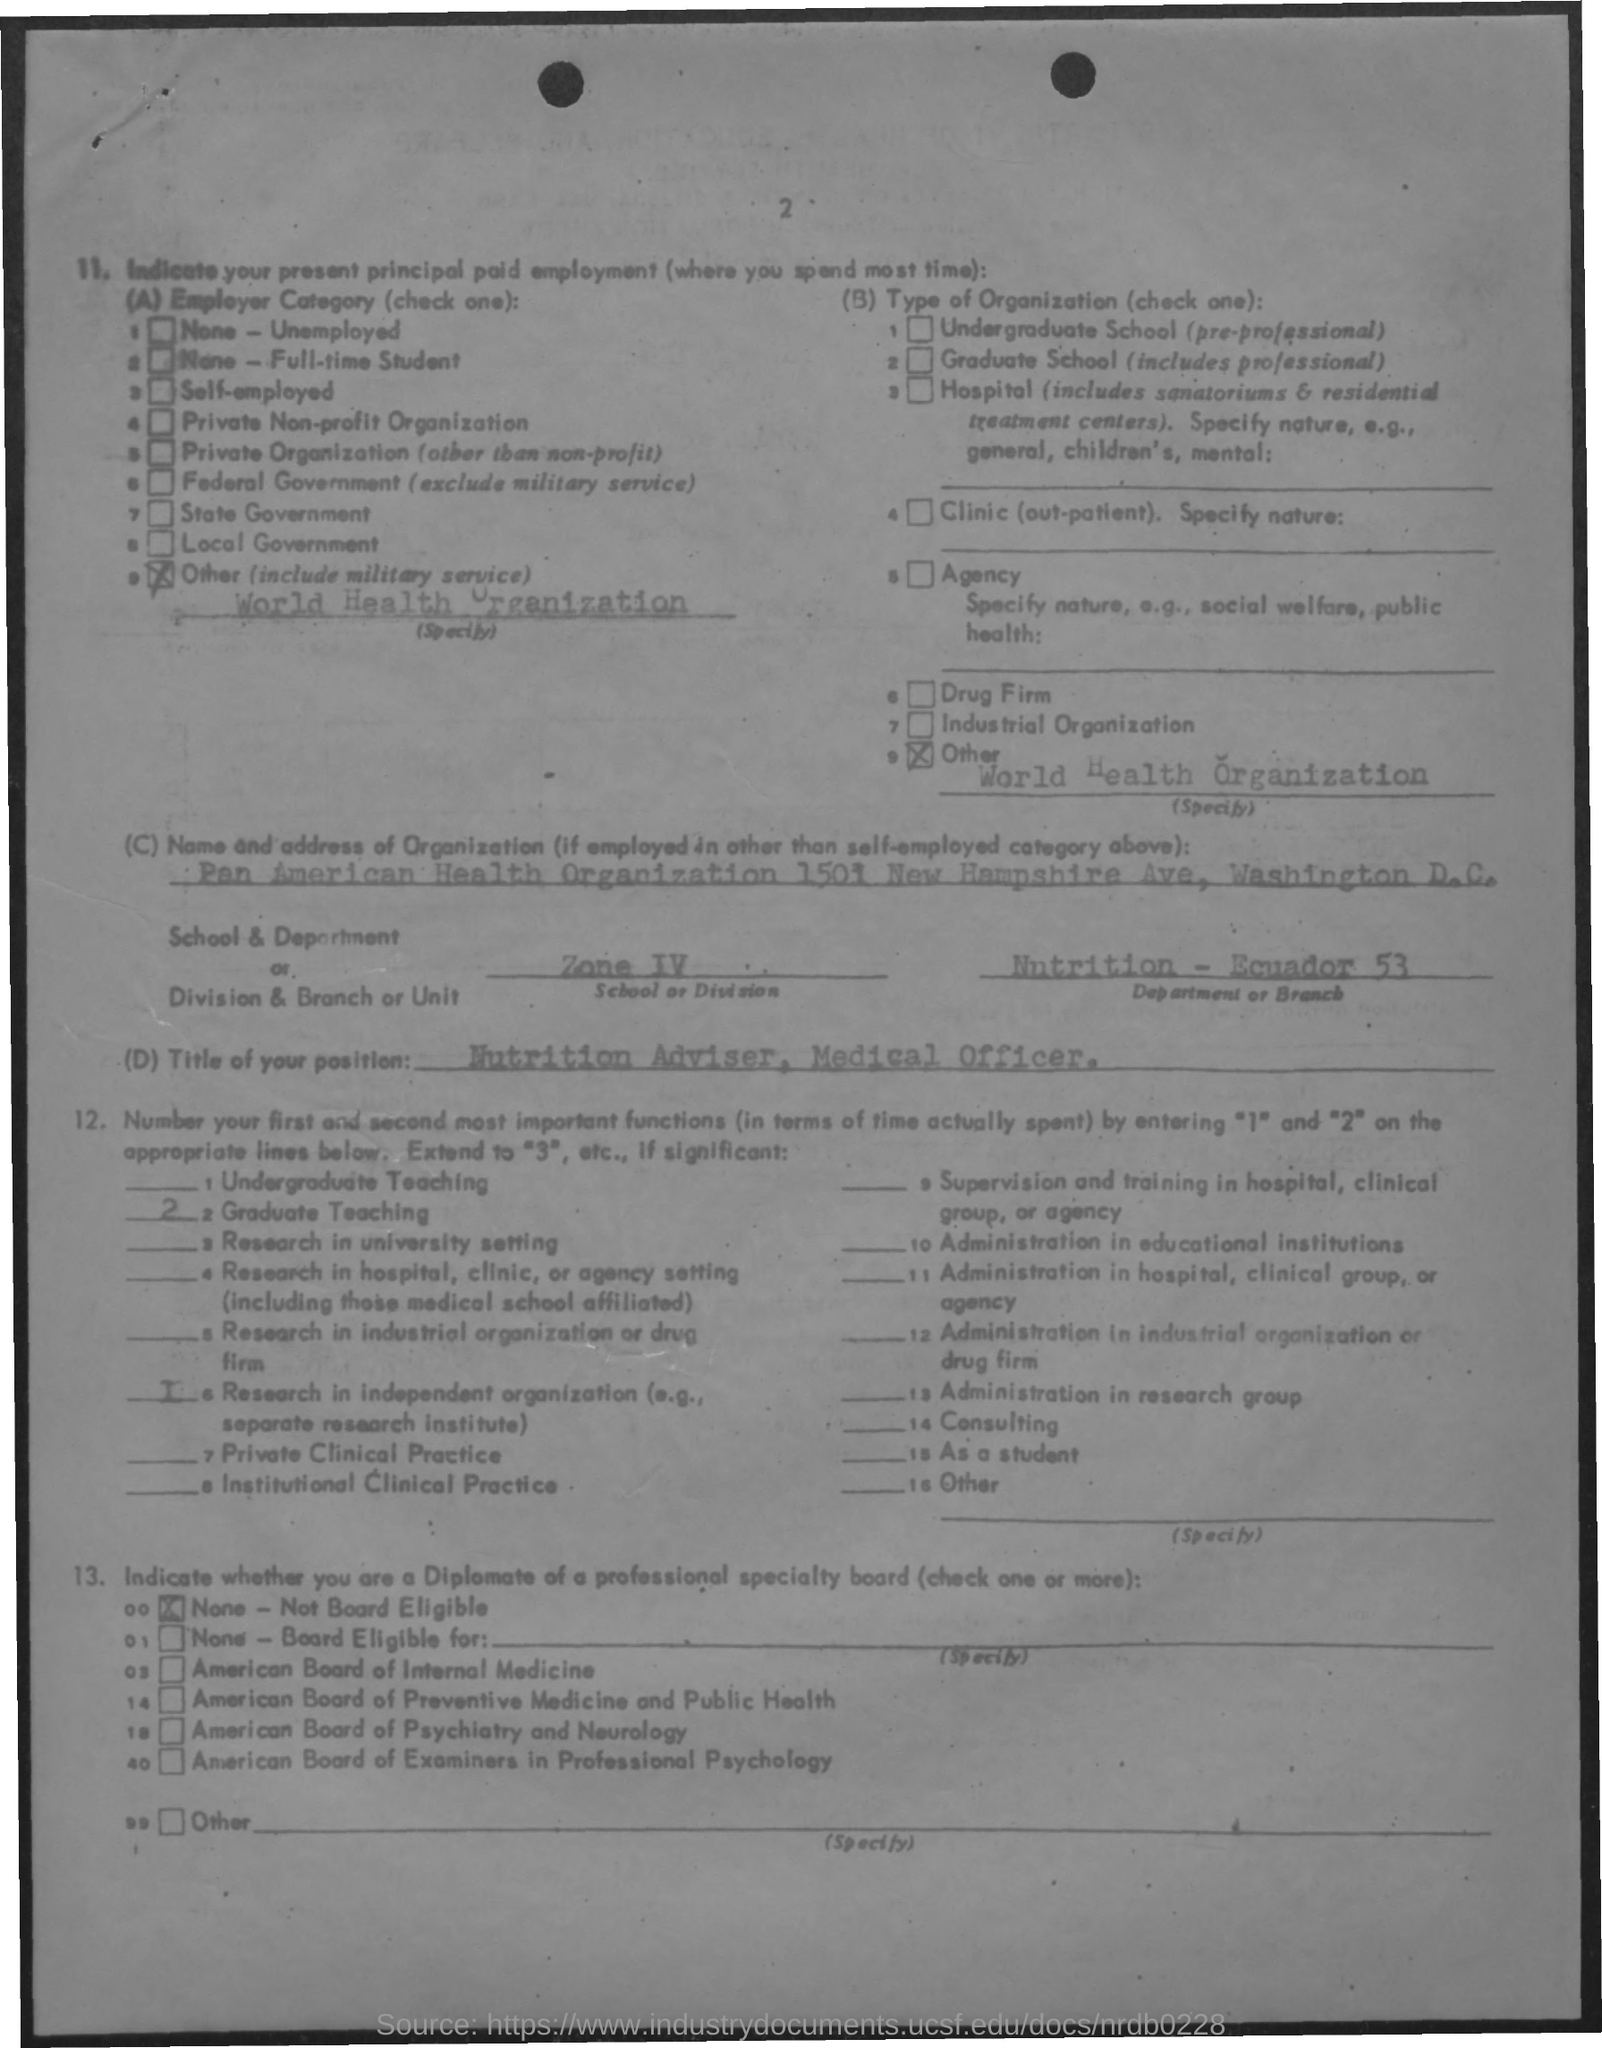Specify some key components in this picture. The applicant is currently employed by the World Health Organization. I am applying for the position of Nutrition Adviser and Medical Officer in your esteemed organization. The applicant belongs to the Nutritional Department in Ecuador, with a total of 53 applicants. There were 2 graduate teachings. 